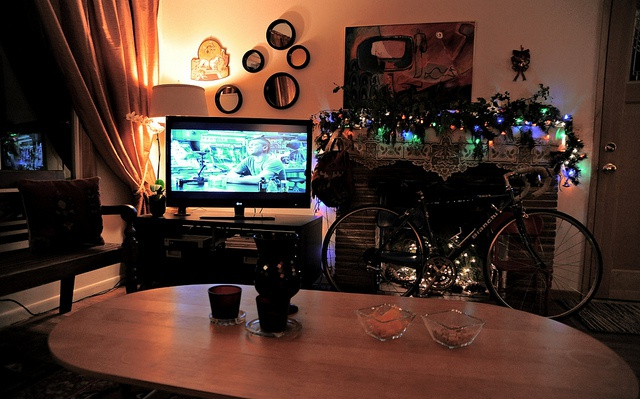Describe the objects in this image and their specific colors. I can see dining table in black, maroon, and brown tones, bicycle in black, maroon, and brown tones, tv in black, white, and turquoise tones, chair in black, brown, and maroon tones, and bench in black, maroon, and brown tones in this image. 